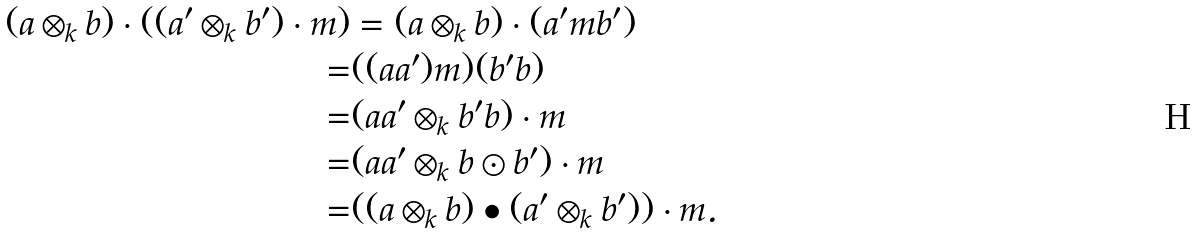<formula> <loc_0><loc_0><loc_500><loc_500>( a \otimes _ { k } b ) \cdot ( ( a ^ { \prime } \otimes _ { k } b ^ { \prime } ) \cdot m ) & = ( a \otimes _ { k } b ) \cdot ( a ^ { \prime } m b ^ { \prime } ) \\ = & ( ( a a ^ { \prime } ) m ) ( b ^ { \prime } b ) \\ = & ( a a ^ { \prime } \otimes _ { k } b ^ { \prime } b ) \cdot m \\ = & ( a a ^ { \prime } \otimes _ { k } b \odot b ^ { \prime } ) \cdot m \\ = & ( ( a \otimes _ { k } b ) \bullet ( a ^ { \prime } \otimes _ { k } b ^ { \prime } ) ) \cdot m .</formula> 